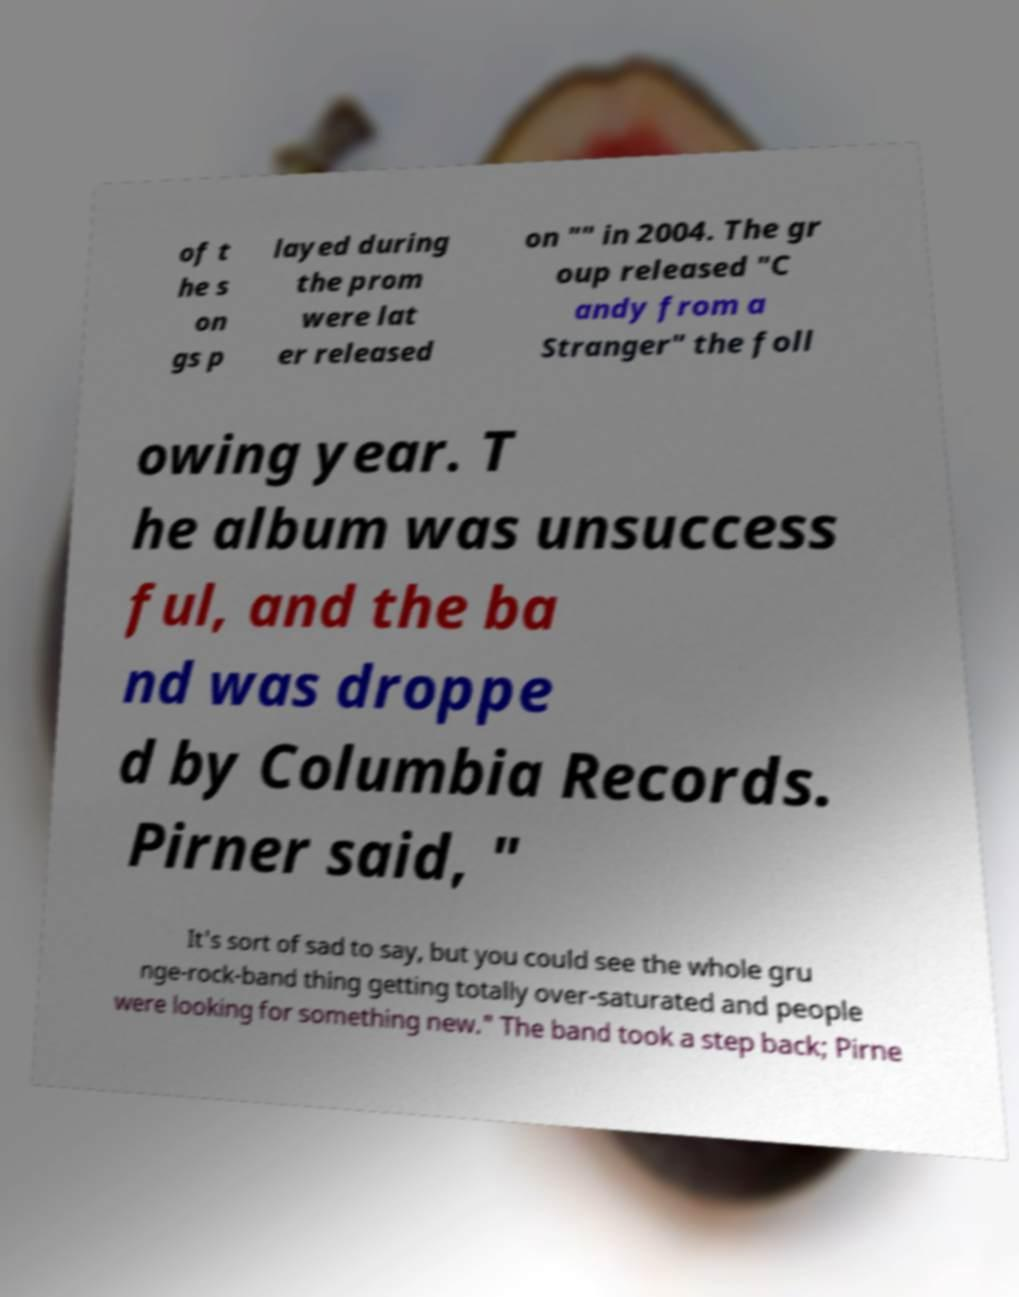For documentation purposes, I need the text within this image transcribed. Could you provide that? of t he s on gs p layed during the prom were lat er released on "" in 2004. The gr oup released "C andy from a Stranger" the foll owing year. T he album was unsuccess ful, and the ba nd was droppe d by Columbia Records. Pirner said, " It's sort of sad to say, but you could see the whole gru nge-rock-band thing getting totally over-saturated and people were looking for something new." The band took a step back; Pirne 